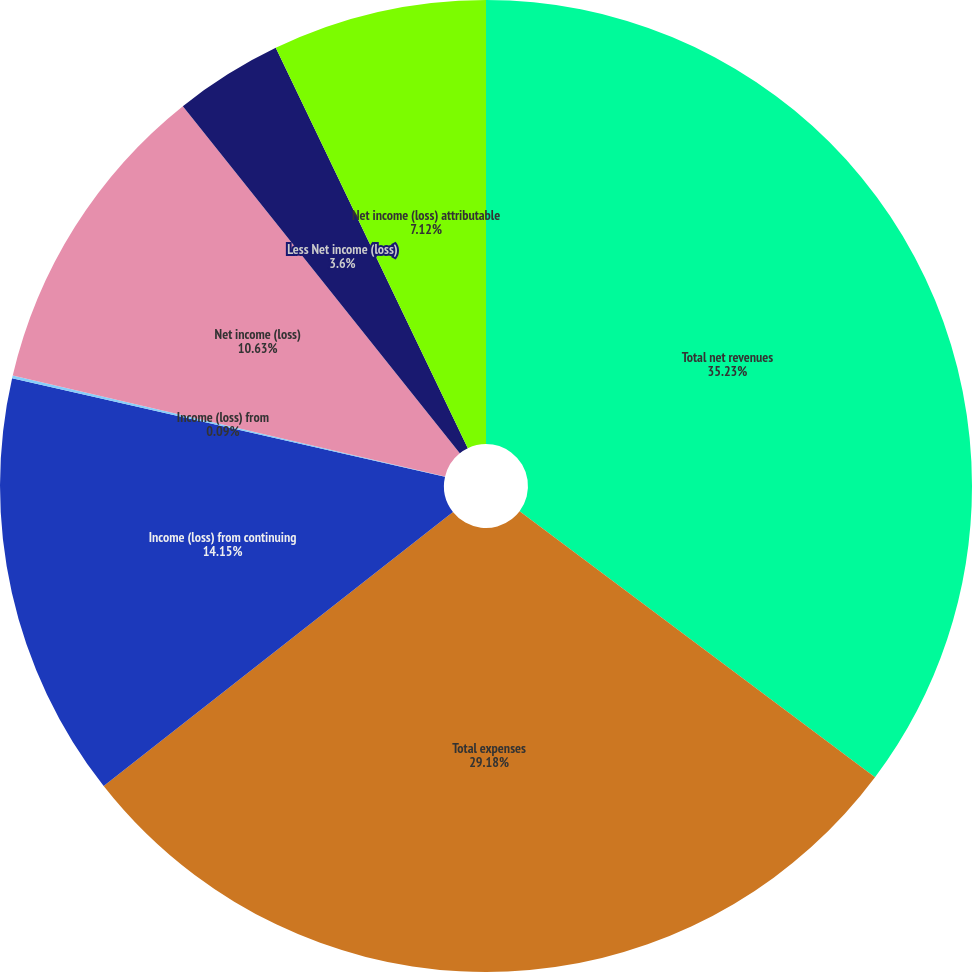Convert chart to OTSL. <chart><loc_0><loc_0><loc_500><loc_500><pie_chart><fcel>Total net revenues<fcel>Total expenses<fcel>Income (loss) from continuing<fcel>Income (loss) from<fcel>Net income (loss)<fcel>Less Net income (loss)<fcel>Net income (loss) attributable<nl><fcel>35.23%<fcel>29.18%<fcel>14.15%<fcel>0.09%<fcel>10.63%<fcel>3.6%<fcel>7.12%<nl></chart> 